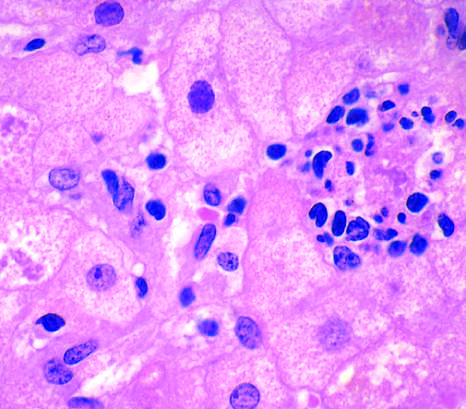what is hepatocyte injury in fatty liver disease associated with?
Answer the question using a single word or phrase. Chronic alcohol use 